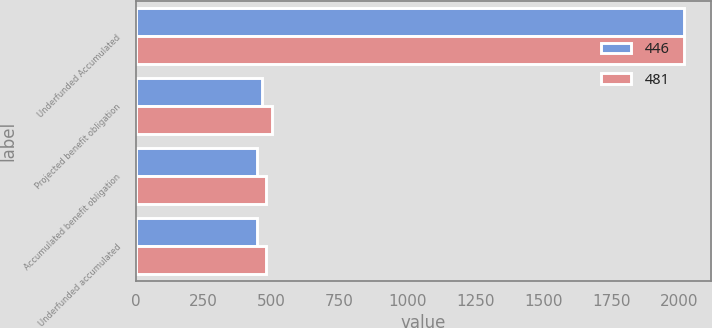Convert chart to OTSL. <chart><loc_0><loc_0><loc_500><loc_500><stacked_bar_chart><ecel><fcel>Underfunded Accumulated<fcel>Projected benefit obligation<fcel>Accumulated benefit obligation<fcel>Underfunded accumulated<nl><fcel>446<fcel>2018<fcel>465<fcel>446<fcel>446<nl><fcel>481<fcel>2017<fcel>501<fcel>481<fcel>481<nl></chart> 